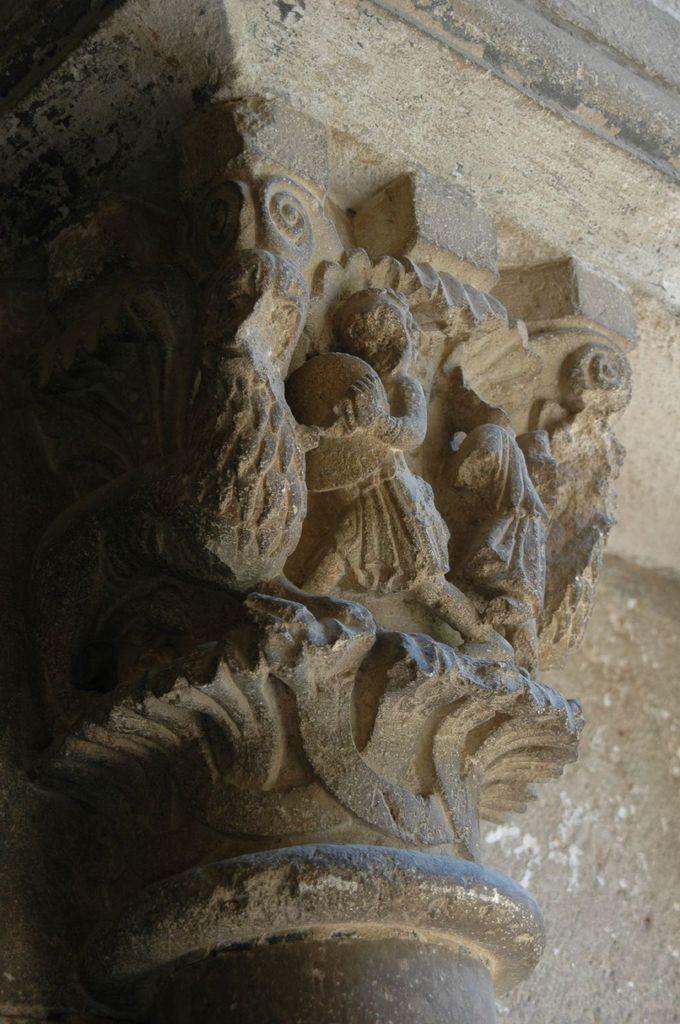Please provide a concise description of this image. In this image I can see few white colour sculptures over here. 